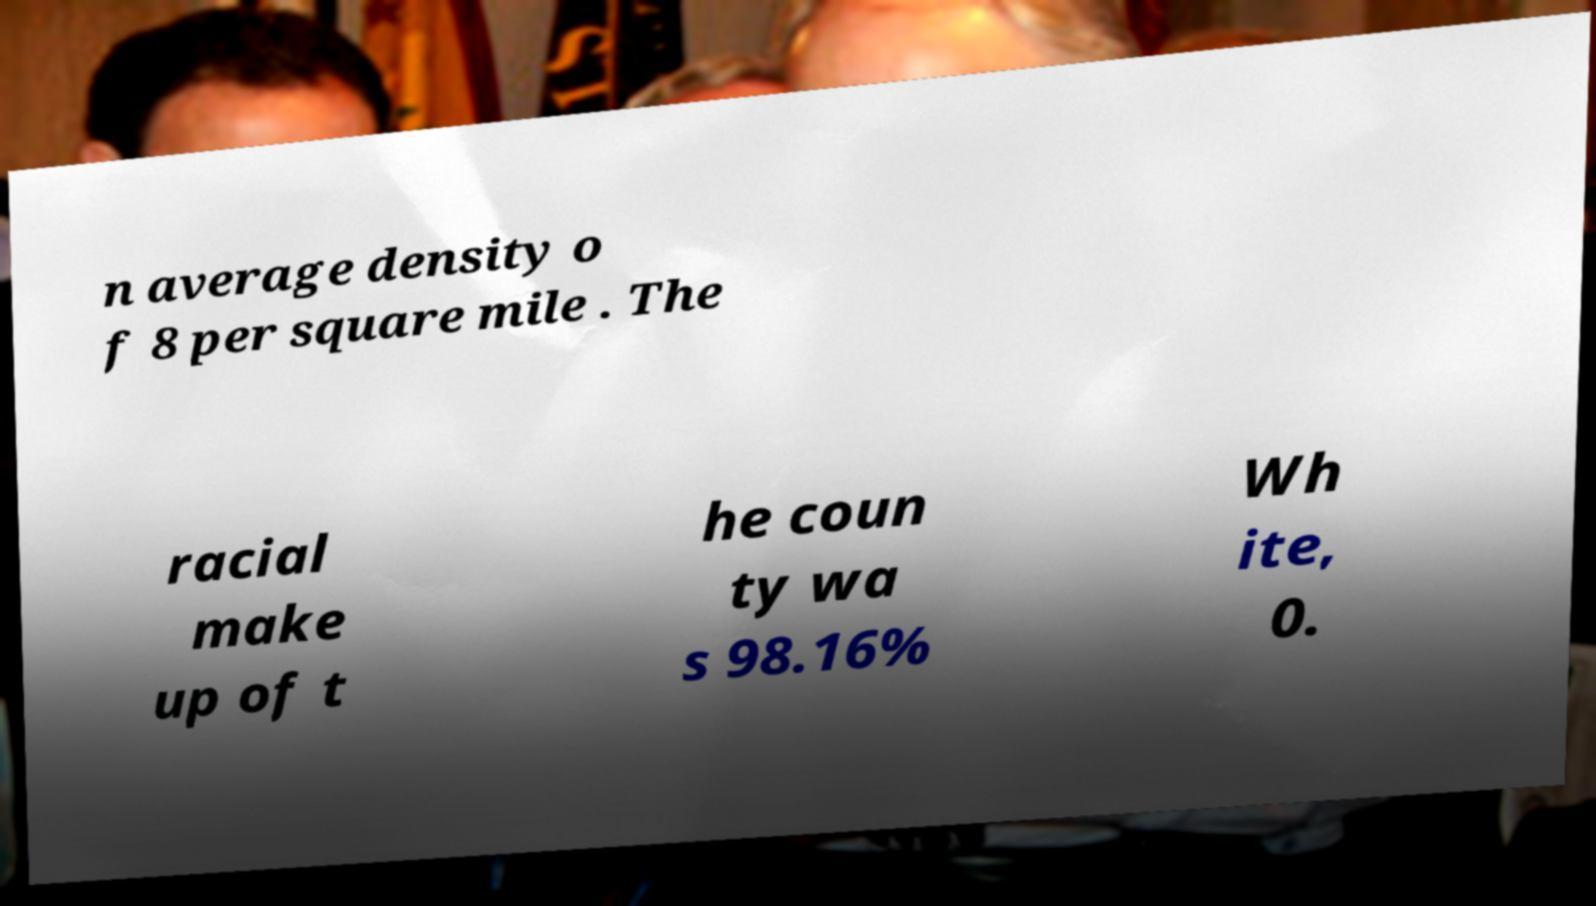Please read and relay the text visible in this image. What does it say? n average density o f 8 per square mile . The racial make up of t he coun ty wa s 98.16% Wh ite, 0. 